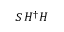Convert formula to latex. <formula><loc_0><loc_0><loc_500><loc_500>S \, H ^ { \dagger } H</formula> 